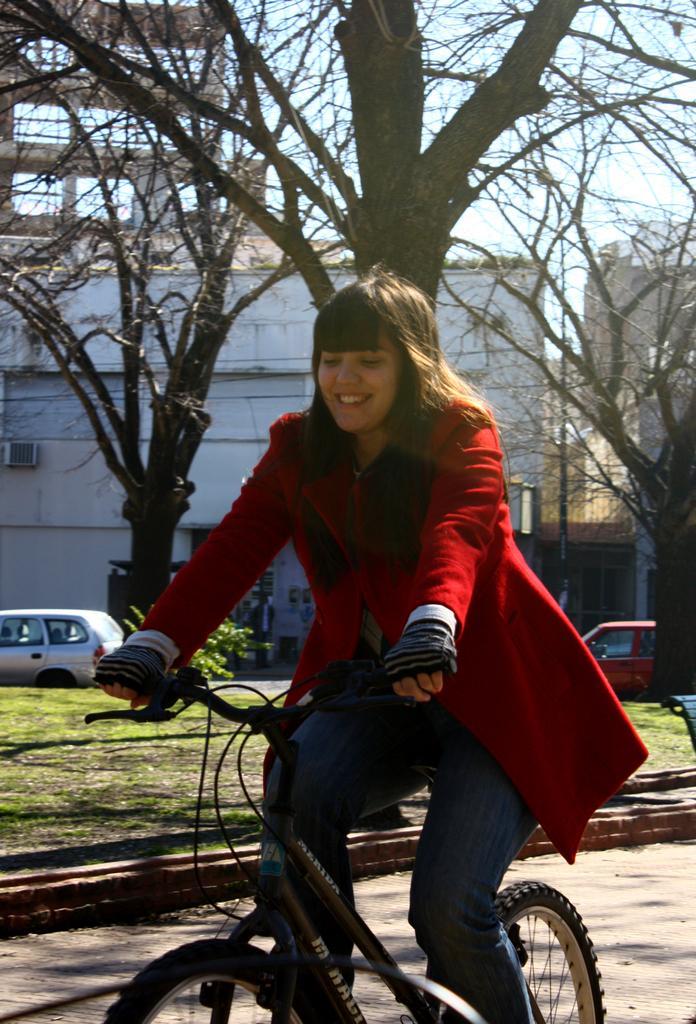In one or two sentences, can you explain what this image depicts? In the image we can see there is a woman who is sitting on bicycle and at the back there are trees and building. 